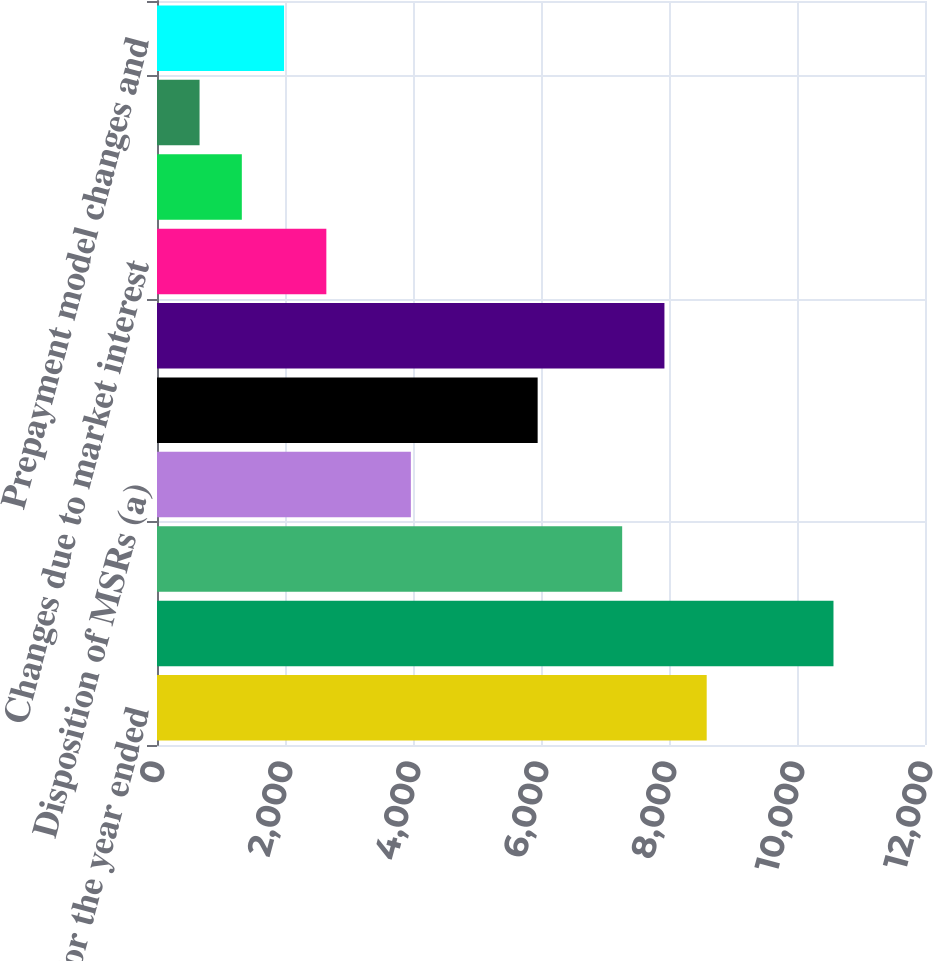Convert chart to OTSL. <chart><loc_0><loc_0><loc_500><loc_500><bar_chart><fcel>As of or for the year ended<fcel>Fair value at beginning of<fcel>Originations of MSRs<fcel>Disposition of MSRs (a)<fcel>Net additions<fcel>Changes due to<fcel>Changes due to market interest<fcel>Projected cash flows (eg cost<fcel>Discount rates<fcel>Prepayment model changes and<nl><fcel>8588.99<fcel>10570<fcel>7268.33<fcel>3966.68<fcel>5947.67<fcel>7928.66<fcel>2646.02<fcel>1325.36<fcel>665.03<fcel>1985.69<nl></chart> 